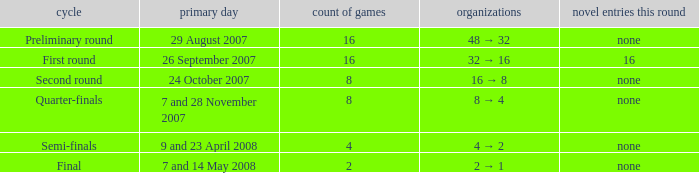What is the New entries this round when the round is the semi-finals? None. 